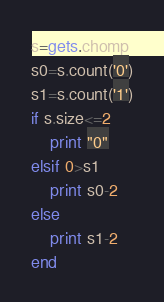<code> <loc_0><loc_0><loc_500><loc_500><_Ruby_>s=gets.chomp
s0=s.count('0')
s1=s.count('1')
if s.size<=2
	print "0"
elsif 0>s1
	print s0-2
else
	print s1-2
end
</code> 